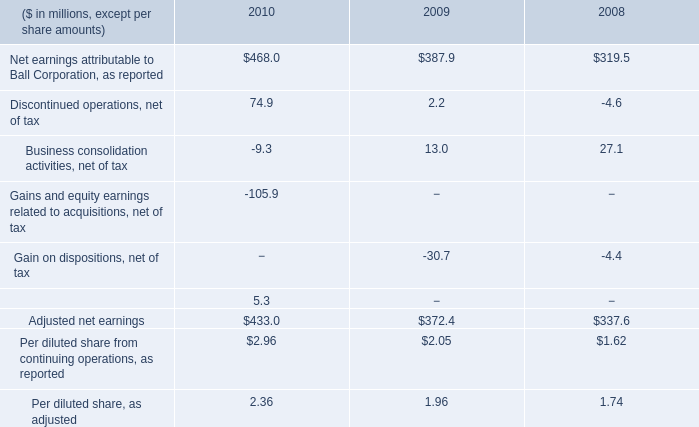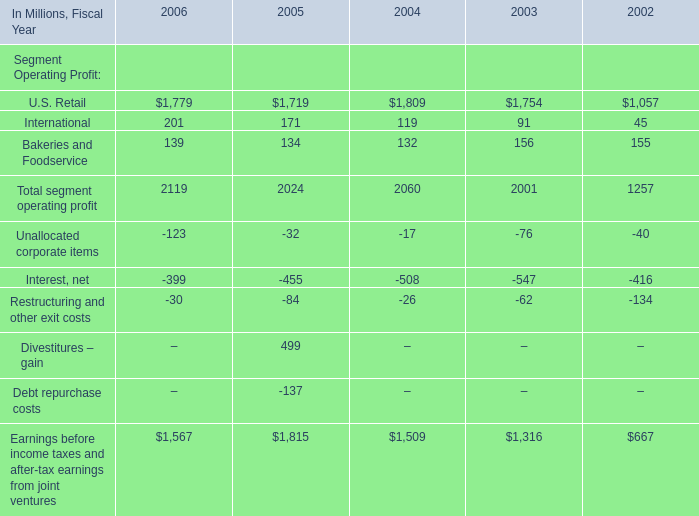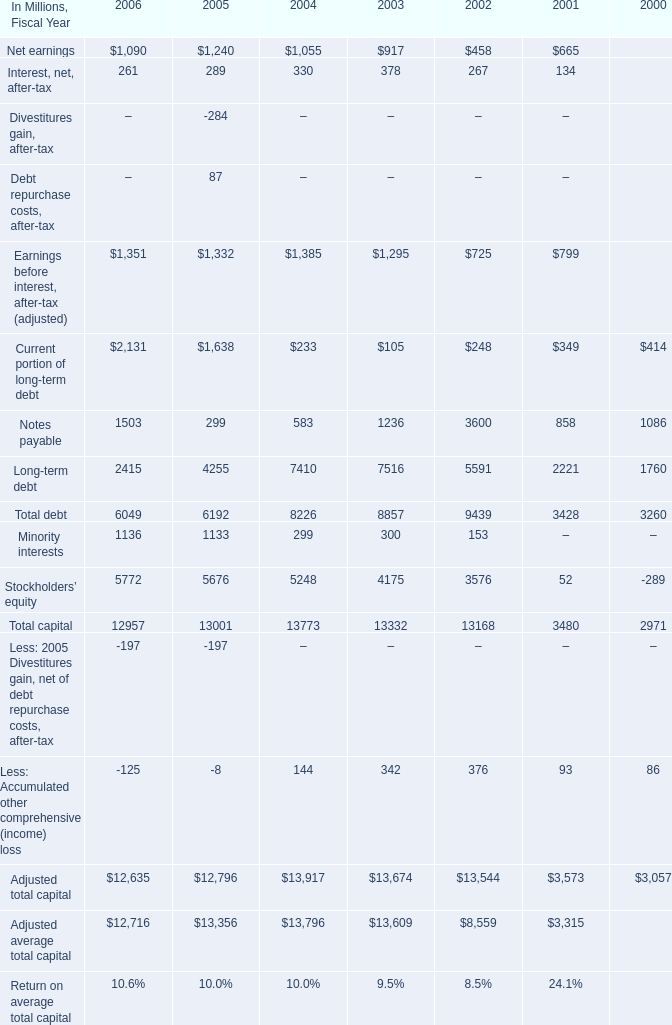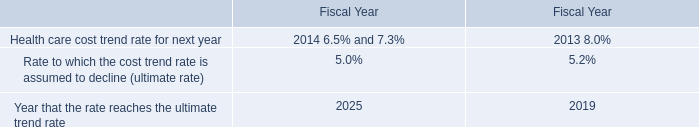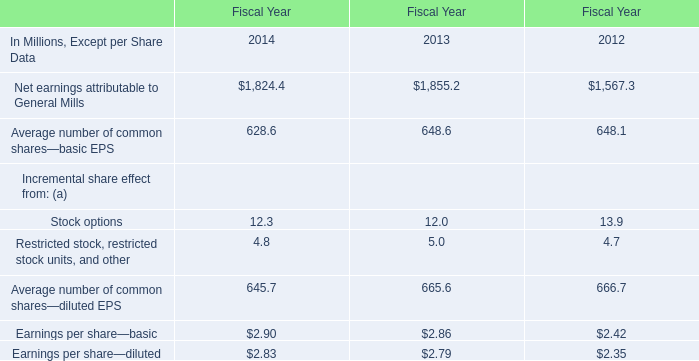"What will Total capital be like in 2007 if it develops with the same increasing rate as current? (in million) 
Computations: ((1 + ((6049 - 6192) / 6192)) * 6049)
Answer: 5909.30249. 